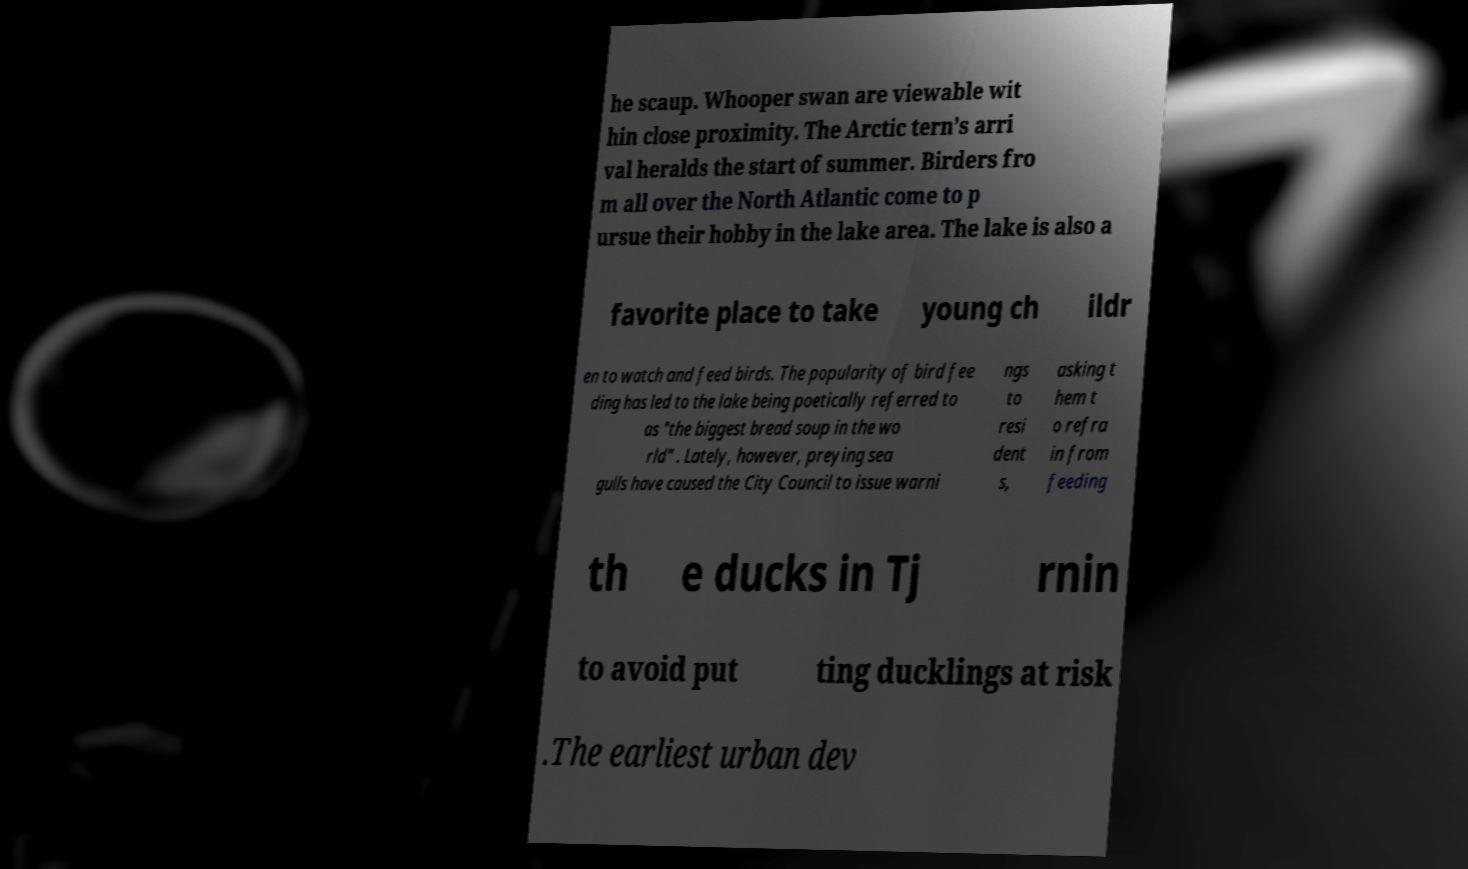I need the written content from this picture converted into text. Can you do that? he scaup. Whooper swan are viewable wit hin close proximity. The Arctic tern’s arri val heralds the start of summer. Birders fro m all over the North Atlantic come to p ursue their hobby in the lake area. The lake is also a favorite place to take young ch ildr en to watch and feed birds. The popularity of bird fee ding has led to the lake being poetically referred to as "the biggest bread soup in the wo rld" . Lately, however, preying sea gulls have caused the City Council to issue warni ngs to resi dent s, asking t hem t o refra in from feeding th e ducks in Tj rnin to avoid put ting ducklings at risk .The earliest urban dev 